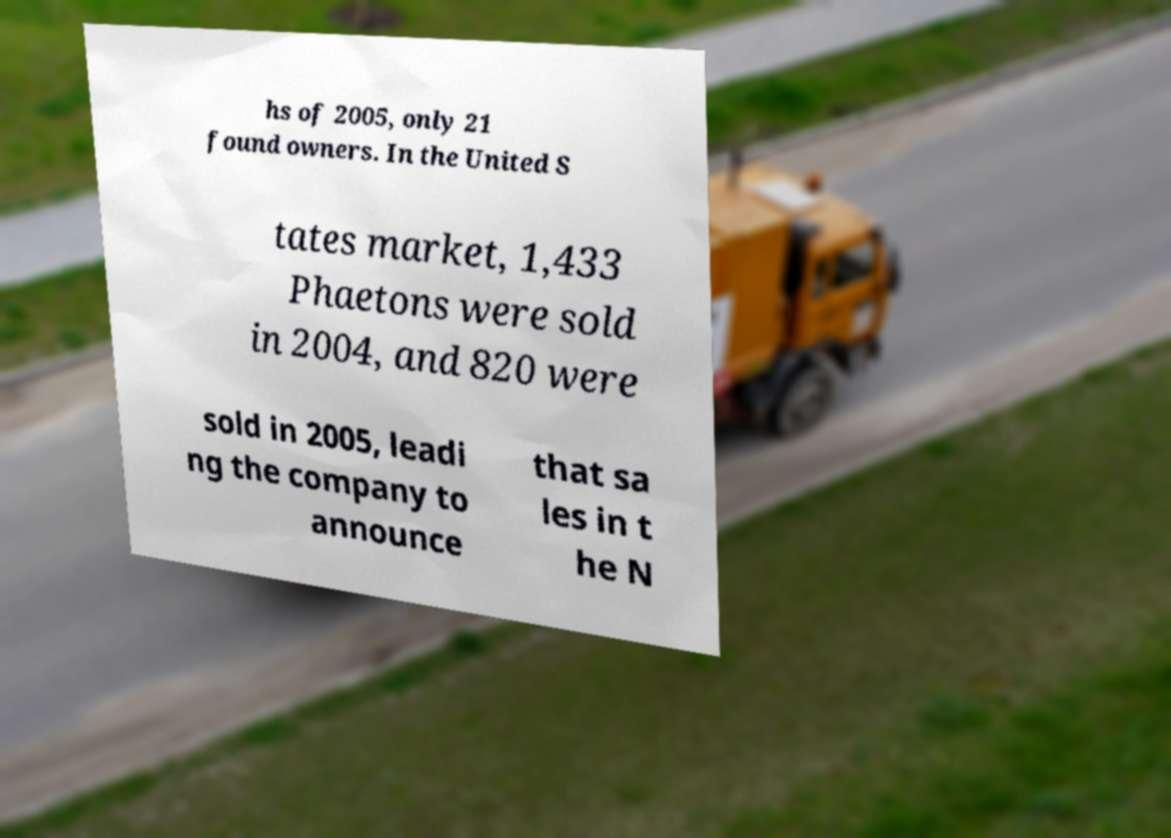Could you assist in decoding the text presented in this image and type it out clearly? hs of 2005, only 21 found owners. In the United S tates market, 1,433 Phaetons were sold in 2004, and 820 were sold in 2005, leadi ng the company to announce that sa les in t he N 